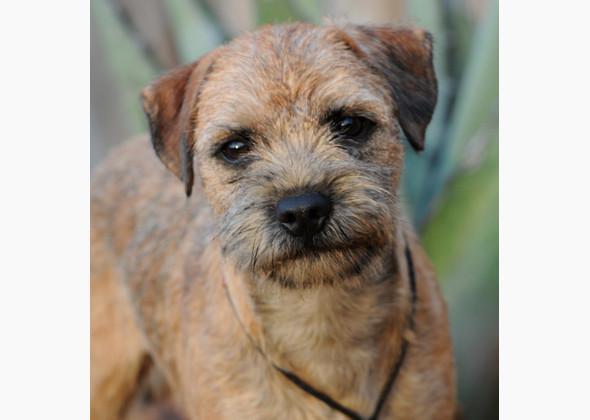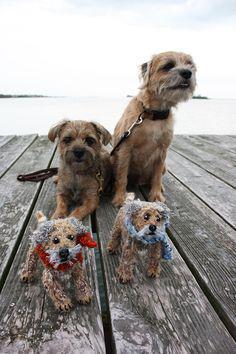The first image is the image on the left, the second image is the image on the right. Examine the images to the left and right. Is the description "the right side image has a dog that has their tongue out" accurate? Answer yes or no. No. The first image is the image on the left, the second image is the image on the right. For the images displayed, is the sentence "None of the dogs' tongues are visible." factually correct? Answer yes or no. Yes. 